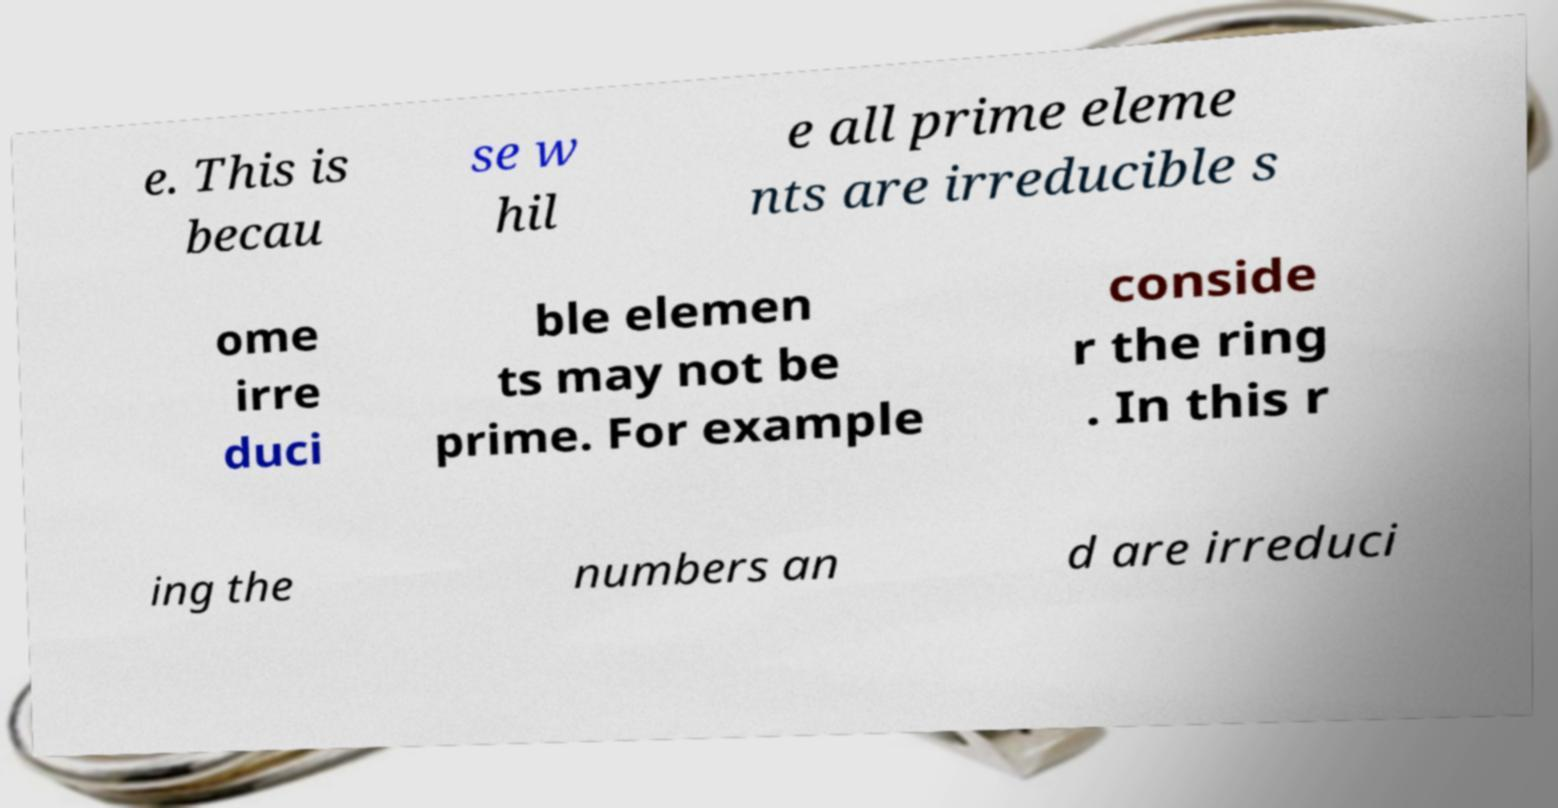Could you assist in decoding the text presented in this image and type it out clearly? e. This is becau se w hil e all prime eleme nts are irreducible s ome irre duci ble elemen ts may not be prime. For example conside r the ring . In this r ing the numbers an d are irreduci 